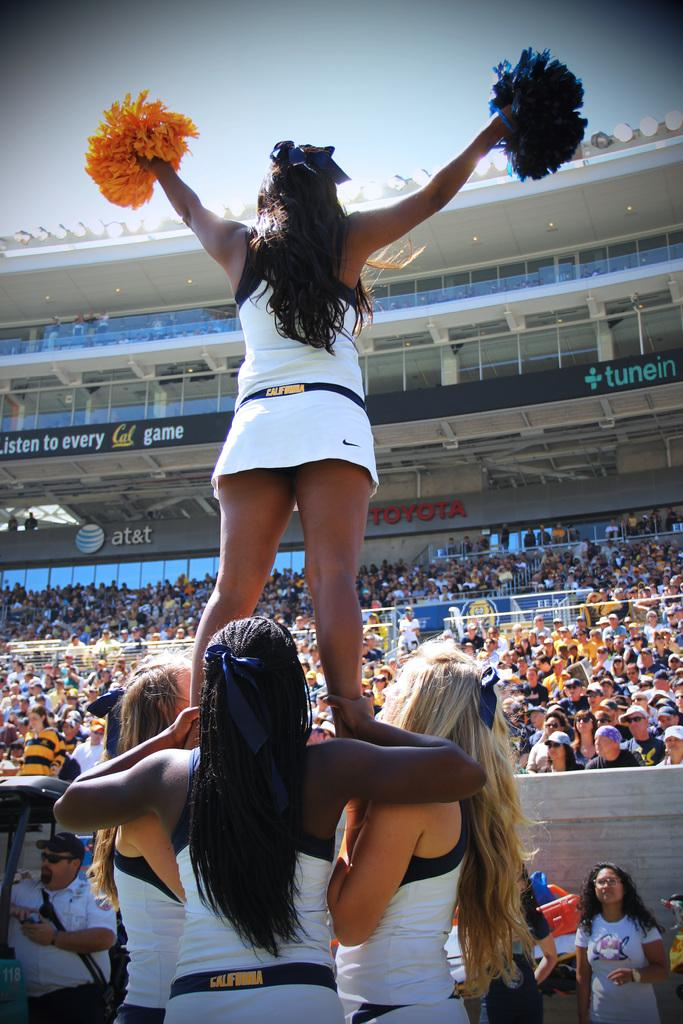<image>
Give a short and clear explanation of the subsequent image. Cheerleaders with California on their belts form a pyramid befoire a huge audience. 